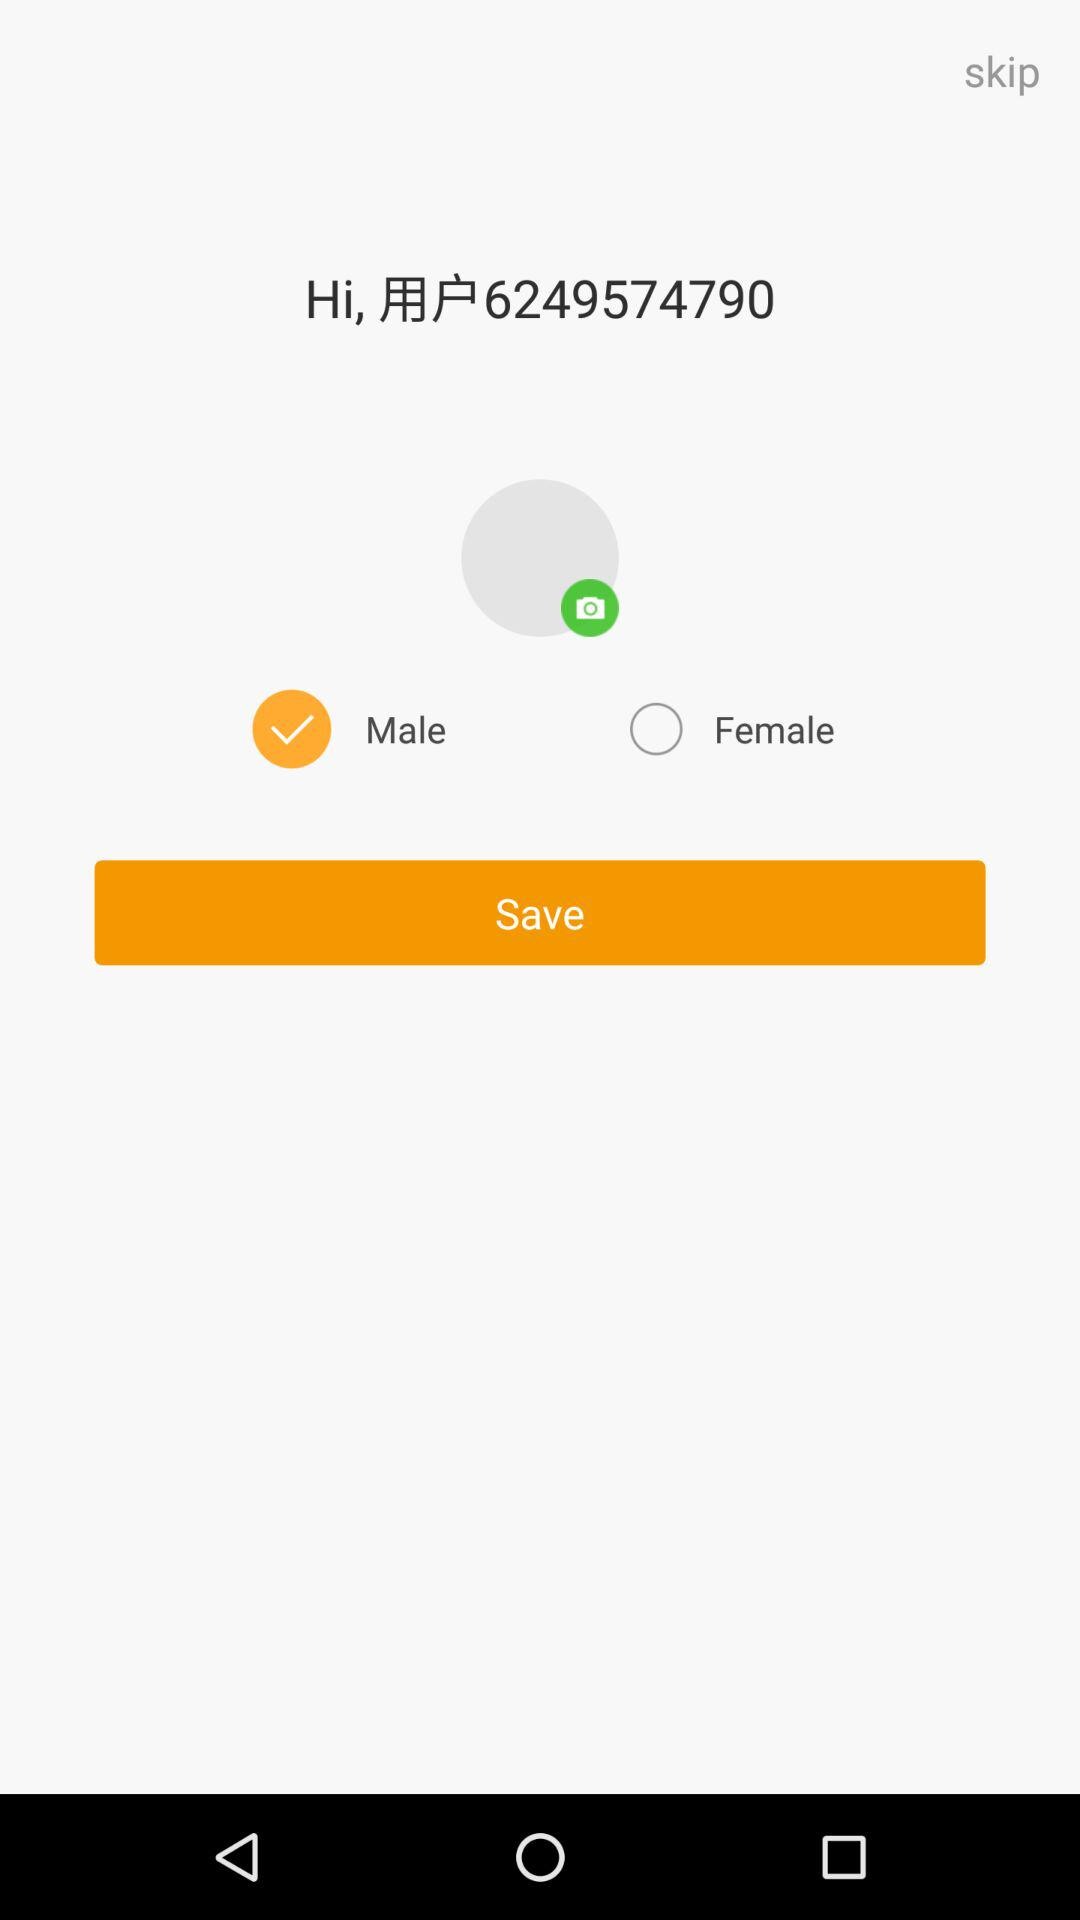What is the status of a male? The status is on. 